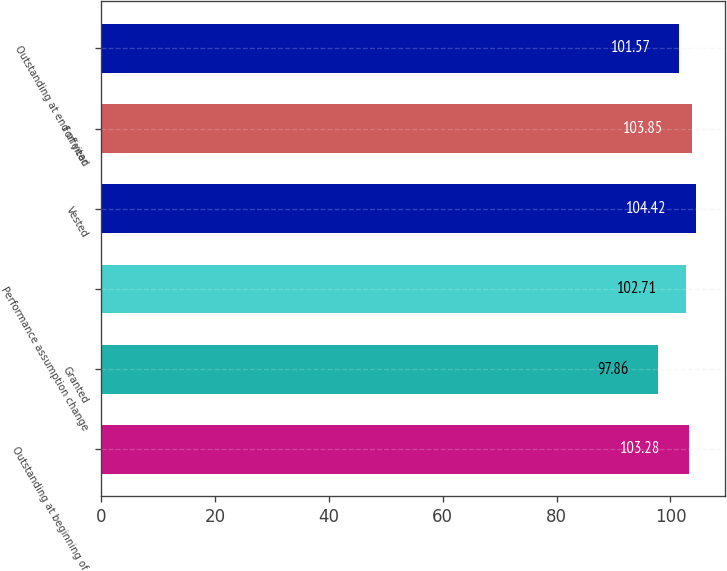Convert chart. <chart><loc_0><loc_0><loc_500><loc_500><bar_chart><fcel>Outstanding at beginning of<fcel>Granted<fcel>Performance assumption change<fcel>Vested<fcel>Forfeited<fcel>Outstanding at end of year<nl><fcel>103.28<fcel>97.86<fcel>102.71<fcel>104.42<fcel>103.85<fcel>101.57<nl></chart> 